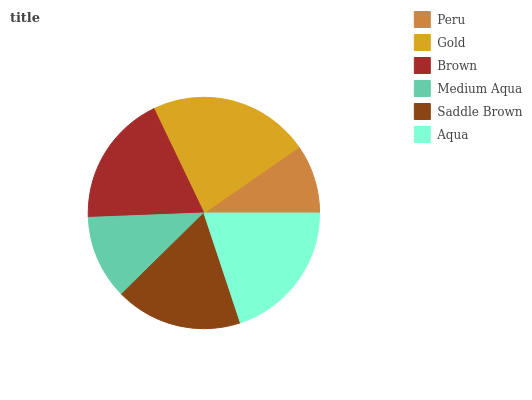Is Peru the minimum?
Answer yes or no. Yes. Is Gold the maximum?
Answer yes or no. Yes. Is Brown the minimum?
Answer yes or no. No. Is Brown the maximum?
Answer yes or no. No. Is Gold greater than Brown?
Answer yes or no. Yes. Is Brown less than Gold?
Answer yes or no. Yes. Is Brown greater than Gold?
Answer yes or no. No. Is Gold less than Brown?
Answer yes or no. No. Is Brown the high median?
Answer yes or no. Yes. Is Saddle Brown the low median?
Answer yes or no. Yes. Is Gold the high median?
Answer yes or no. No. Is Medium Aqua the low median?
Answer yes or no. No. 